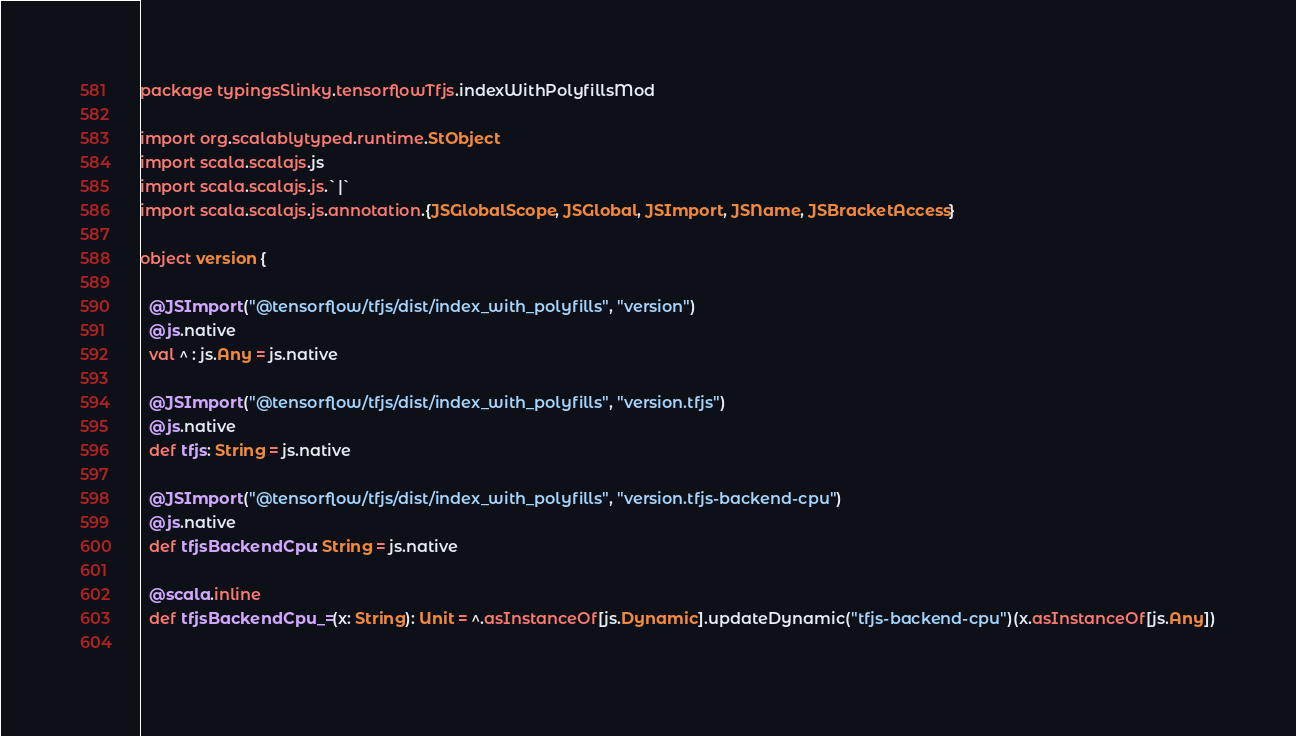Convert code to text. <code><loc_0><loc_0><loc_500><loc_500><_Scala_>package typingsSlinky.tensorflowTfjs.indexWithPolyfillsMod

import org.scalablytyped.runtime.StObject
import scala.scalajs.js
import scala.scalajs.js.`|`
import scala.scalajs.js.annotation.{JSGlobalScope, JSGlobal, JSImport, JSName, JSBracketAccess}

object version {
  
  @JSImport("@tensorflow/tfjs/dist/index_with_polyfills", "version")
  @js.native
  val ^ : js.Any = js.native
  
  @JSImport("@tensorflow/tfjs/dist/index_with_polyfills", "version.tfjs")
  @js.native
  def tfjs: String = js.native
  
  @JSImport("@tensorflow/tfjs/dist/index_with_polyfills", "version.tfjs-backend-cpu")
  @js.native
  def tfjsBackendCpu: String = js.native
  
  @scala.inline
  def tfjsBackendCpu_=(x: String): Unit = ^.asInstanceOf[js.Dynamic].updateDynamic("tfjs-backend-cpu")(x.asInstanceOf[js.Any])
  </code> 